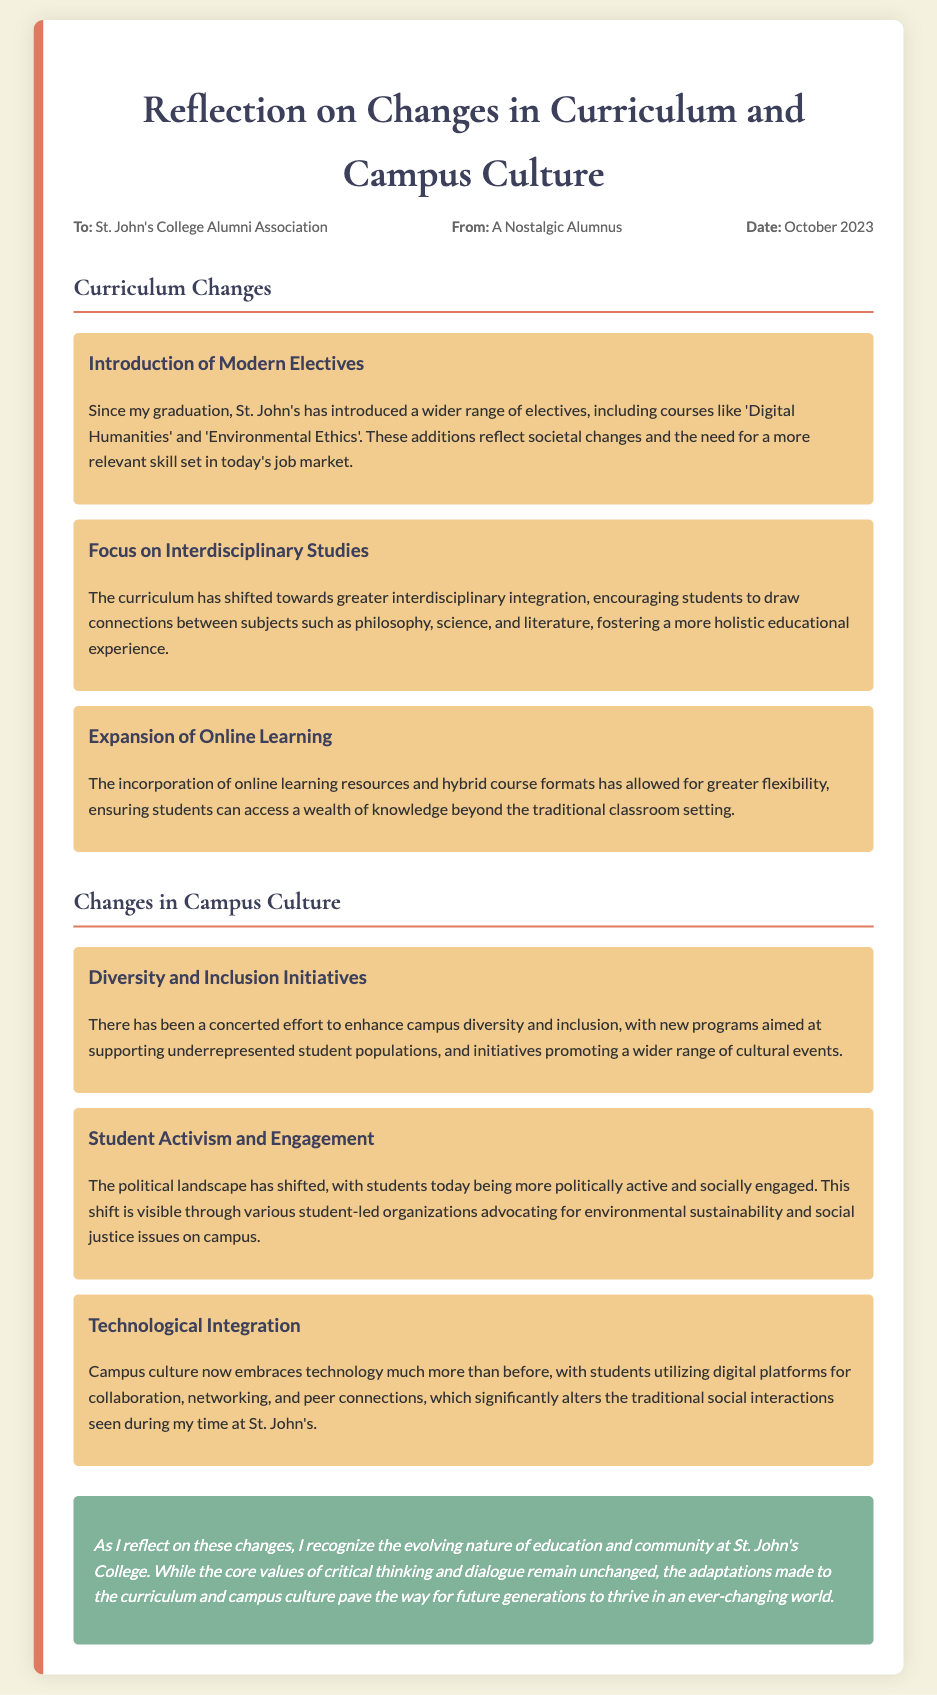What new electives have been introduced? The document lists 'Digital Humanities' and 'Environmental Ethics' as new electives introduced since graduation.
Answer: Digital Humanities, Environmental Ethics What has the curriculum shifted towards? The curriculum has shifted towards greater interdisciplinary integration, encouraging connections between various subjects.
Answer: Interdisciplinary integration What initiative has been introduced for underrepresented populations? The document mentions new programs aimed at supporting underrepresented student populations as part of diversity and inclusion initiatives.
Answer: Diversity and inclusion initiatives How has campus culture embraced technology? The campus culture embraces technology by utilizing digital platforms for collaboration, networking, and peer connections.
Answer: Digital platforms for collaboration What is the date of the memo? The date of the memo is explicitly noted in the document as October 2023.
Answer: October 2023 What aspect of student engagement has changed? The political landscape has shifted, with students today being more politically active and socially engaged.
Answer: More politically active and socially engaged What core values remain unchanged at St. John's College? The core values of critical thinking and dialogue are stated to remain unchanged.
Answer: Critical thinking and dialogue What is the conclusion regarding the changes? The conclusion reflects on the evolving nature of education and community while maintaining core values.
Answer: Evolving nature of education and community 